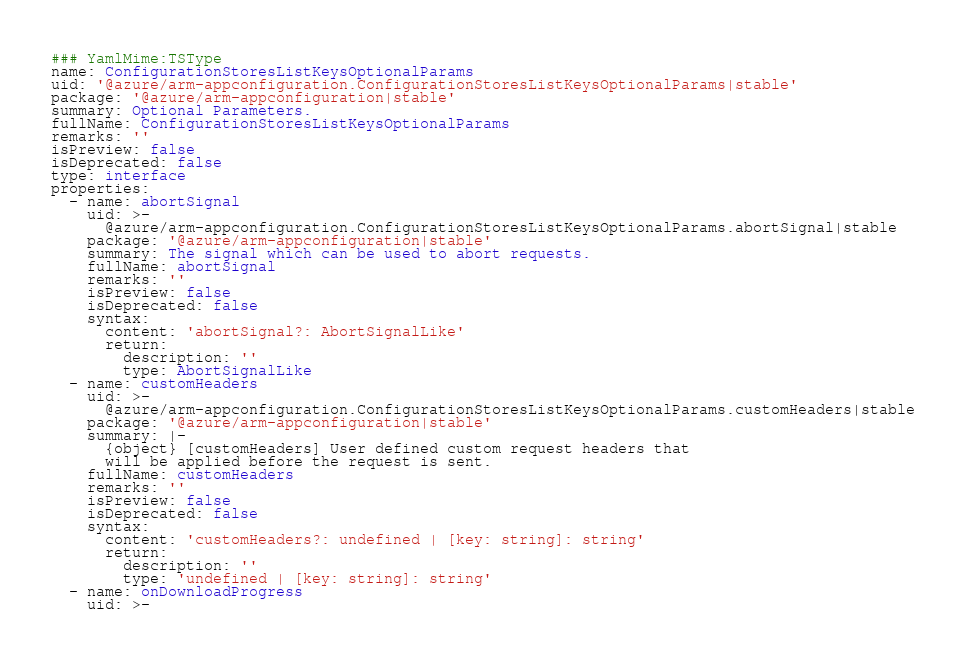Convert code to text. <code><loc_0><loc_0><loc_500><loc_500><_YAML_>### YamlMime:TSType
name: ConfigurationStoresListKeysOptionalParams
uid: '@azure/arm-appconfiguration.ConfigurationStoresListKeysOptionalParams|stable'
package: '@azure/arm-appconfiguration|stable'
summary: Optional Parameters.
fullName: ConfigurationStoresListKeysOptionalParams
remarks: ''
isPreview: false
isDeprecated: false
type: interface
properties:
  - name: abortSignal
    uid: >-
      @azure/arm-appconfiguration.ConfigurationStoresListKeysOptionalParams.abortSignal|stable
    package: '@azure/arm-appconfiguration|stable'
    summary: The signal which can be used to abort requests.
    fullName: abortSignal
    remarks: ''
    isPreview: false
    isDeprecated: false
    syntax:
      content: 'abortSignal?: AbortSignalLike'
      return:
        description: ''
        type: AbortSignalLike
  - name: customHeaders
    uid: >-
      @azure/arm-appconfiguration.ConfigurationStoresListKeysOptionalParams.customHeaders|stable
    package: '@azure/arm-appconfiguration|stable'
    summary: |-
      {object} [customHeaders] User defined custom request headers that
      will be applied before the request is sent.
    fullName: customHeaders
    remarks: ''
    isPreview: false
    isDeprecated: false
    syntax:
      content: 'customHeaders?: undefined | [key: string]: string'
      return:
        description: ''
        type: 'undefined | [key: string]: string'
  - name: onDownloadProgress
    uid: >-</code> 